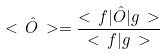Convert formula to latex. <formula><loc_0><loc_0><loc_500><loc_500>< \, \hat { O } \, > = \frac { < \, f | \hat { O } | g \, > } { < \, f | g \, > }</formula> 